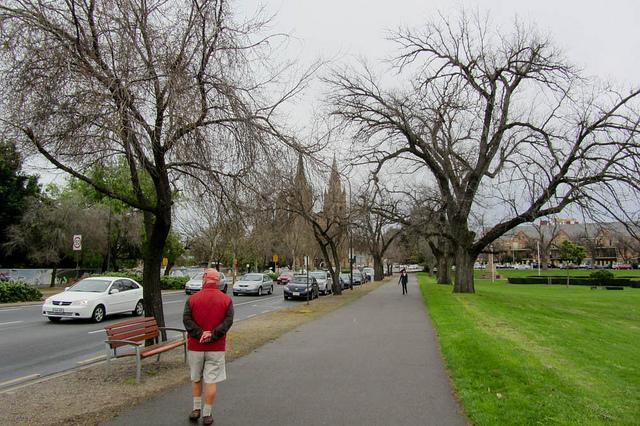What type trees are shown in the area nearest the red shirted walker?

Choices:
A) fern
B) palm
C) evergreen
D) deciduous deciduous 